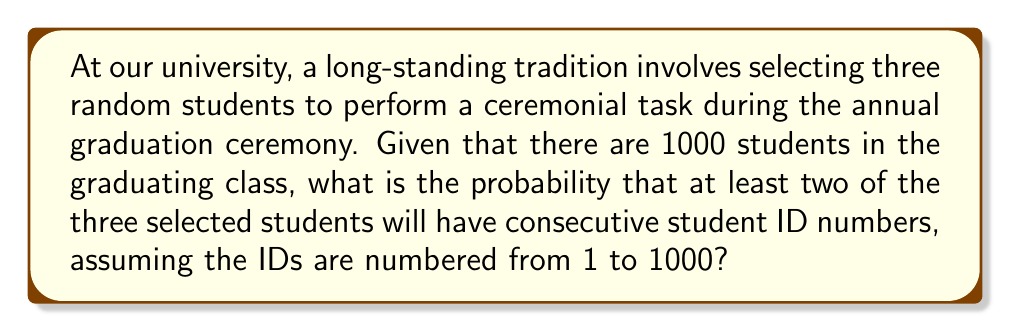Can you answer this question? Let's approach this step-by-step:

1) First, we need to calculate the probability of selecting at least two consecutive numbers out of three draws from 1 to 1000.

2) It's easier to calculate the probability of the complement event (not selecting any consecutive numbers) and then subtract from 1.

3) The probability of not selecting any consecutive numbers can be calculated as follows:

   a) For the first number, we have 1000 choices.
   
   b) For the second number, we can't choose the number immediately before or after the first number, so we have 997 choices.
   
   c) For the third number, we can't choose the numbers immediately before or after the first two numbers, so we have 996 choices.

4) The total number of ways to select 3 numbers out of 1000 is $\binom{1000}{3}$.

5) Therefore, the probability of not selecting any consecutive numbers is:

   $$P(\text{no consecutive}) = \frac{1000 \cdot 997 \cdot 996}{\binom{1000}{3}}$$

6) We can calculate $\binom{1000}{3}$ as:

   $$\binom{1000}{3} = \frac{1000 \cdot 999 \cdot 998}{3 \cdot 2 \cdot 1} = 166,167,000$$

7) Now we can calculate:

   $$P(\text{no consecutive}) = \frac{1000 \cdot 997 \cdot 996}{166,167,000} \approx 0.9970$$

8) Therefore, the probability of selecting at least two consecutive numbers is:

   $$P(\text{at least two consecutive}) = 1 - P(\text{no consecutive}) \approx 1 - 0.9970 = 0.0030$$
Answer: $0.0030$ or $0.30\%$ 